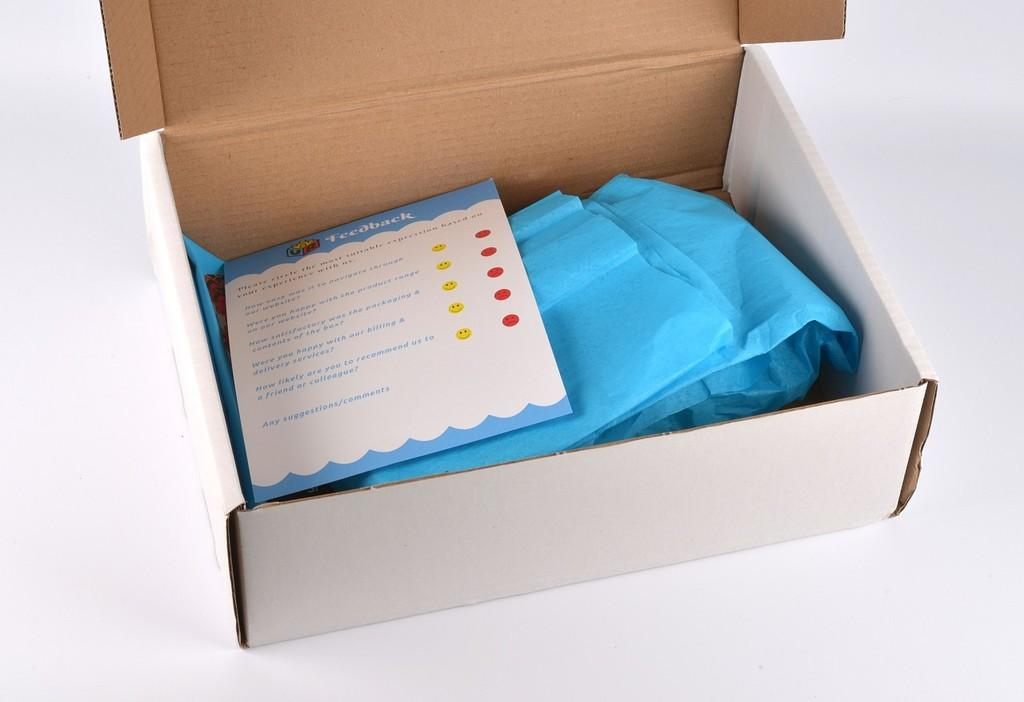What object is present in the image that is typically used for storage or packaging? There is a cardboard box in the image. What color is the cardboard box? The cardboard box is white. What is inside the cardboard box? There is a paper inside the cardboard box. What color is the cover of the cardboard box? The cover of the cardboard box is blue. Can you see any copper elements in the image? There is no copper present in the image. How many cherries are on top of the cardboard box? There are no cherries present in the image. 